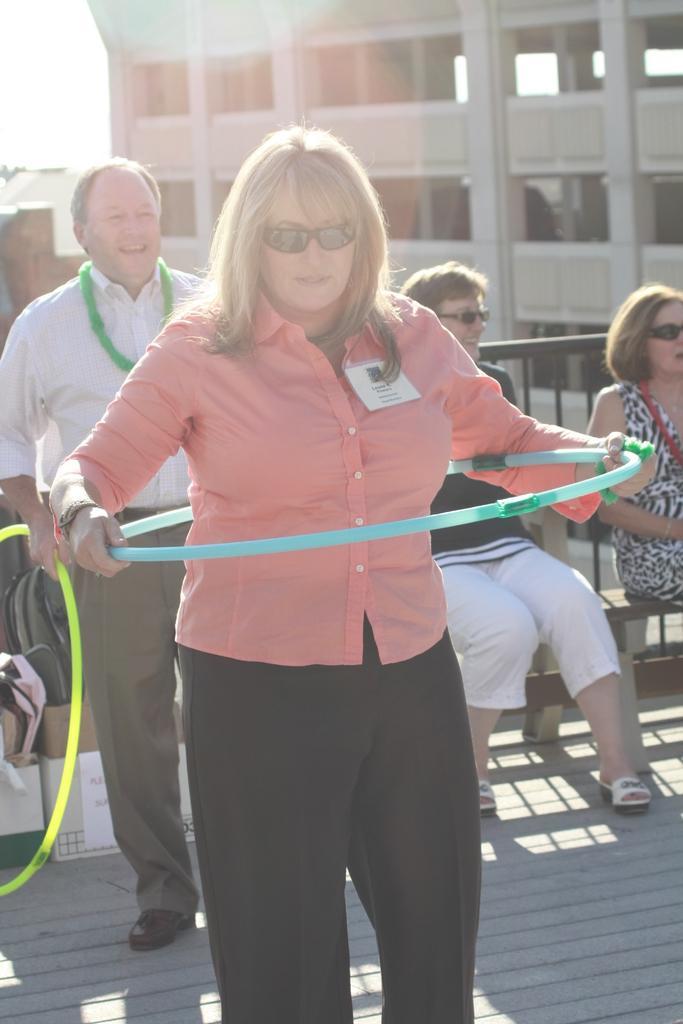Describe this image in one or two sentences. In this image in front there are two people holding the ropes. Behind them there are a few objects. On the right side of the image there are two people sitting on the bench. There is a metal fence. In the background of the image there are buildings and sky. 